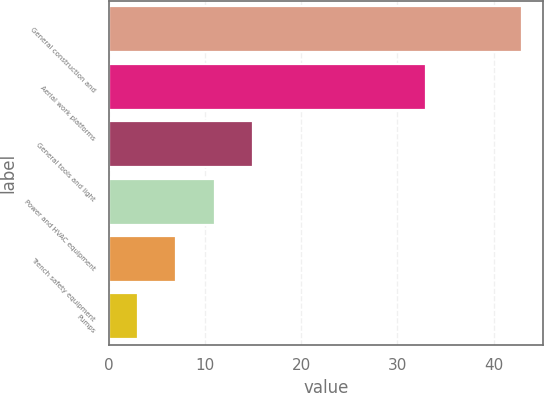Convert chart. <chart><loc_0><loc_0><loc_500><loc_500><bar_chart><fcel>General construction and<fcel>Aerial work platforms<fcel>General tools and light<fcel>Power and HVAC equipment<fcel>Trench safety equipment<fcel>Pumps<nl><fcel>43<fcel>33<fcel>15<fcel>11<fcel>7<fcel>3<nl></chart> 